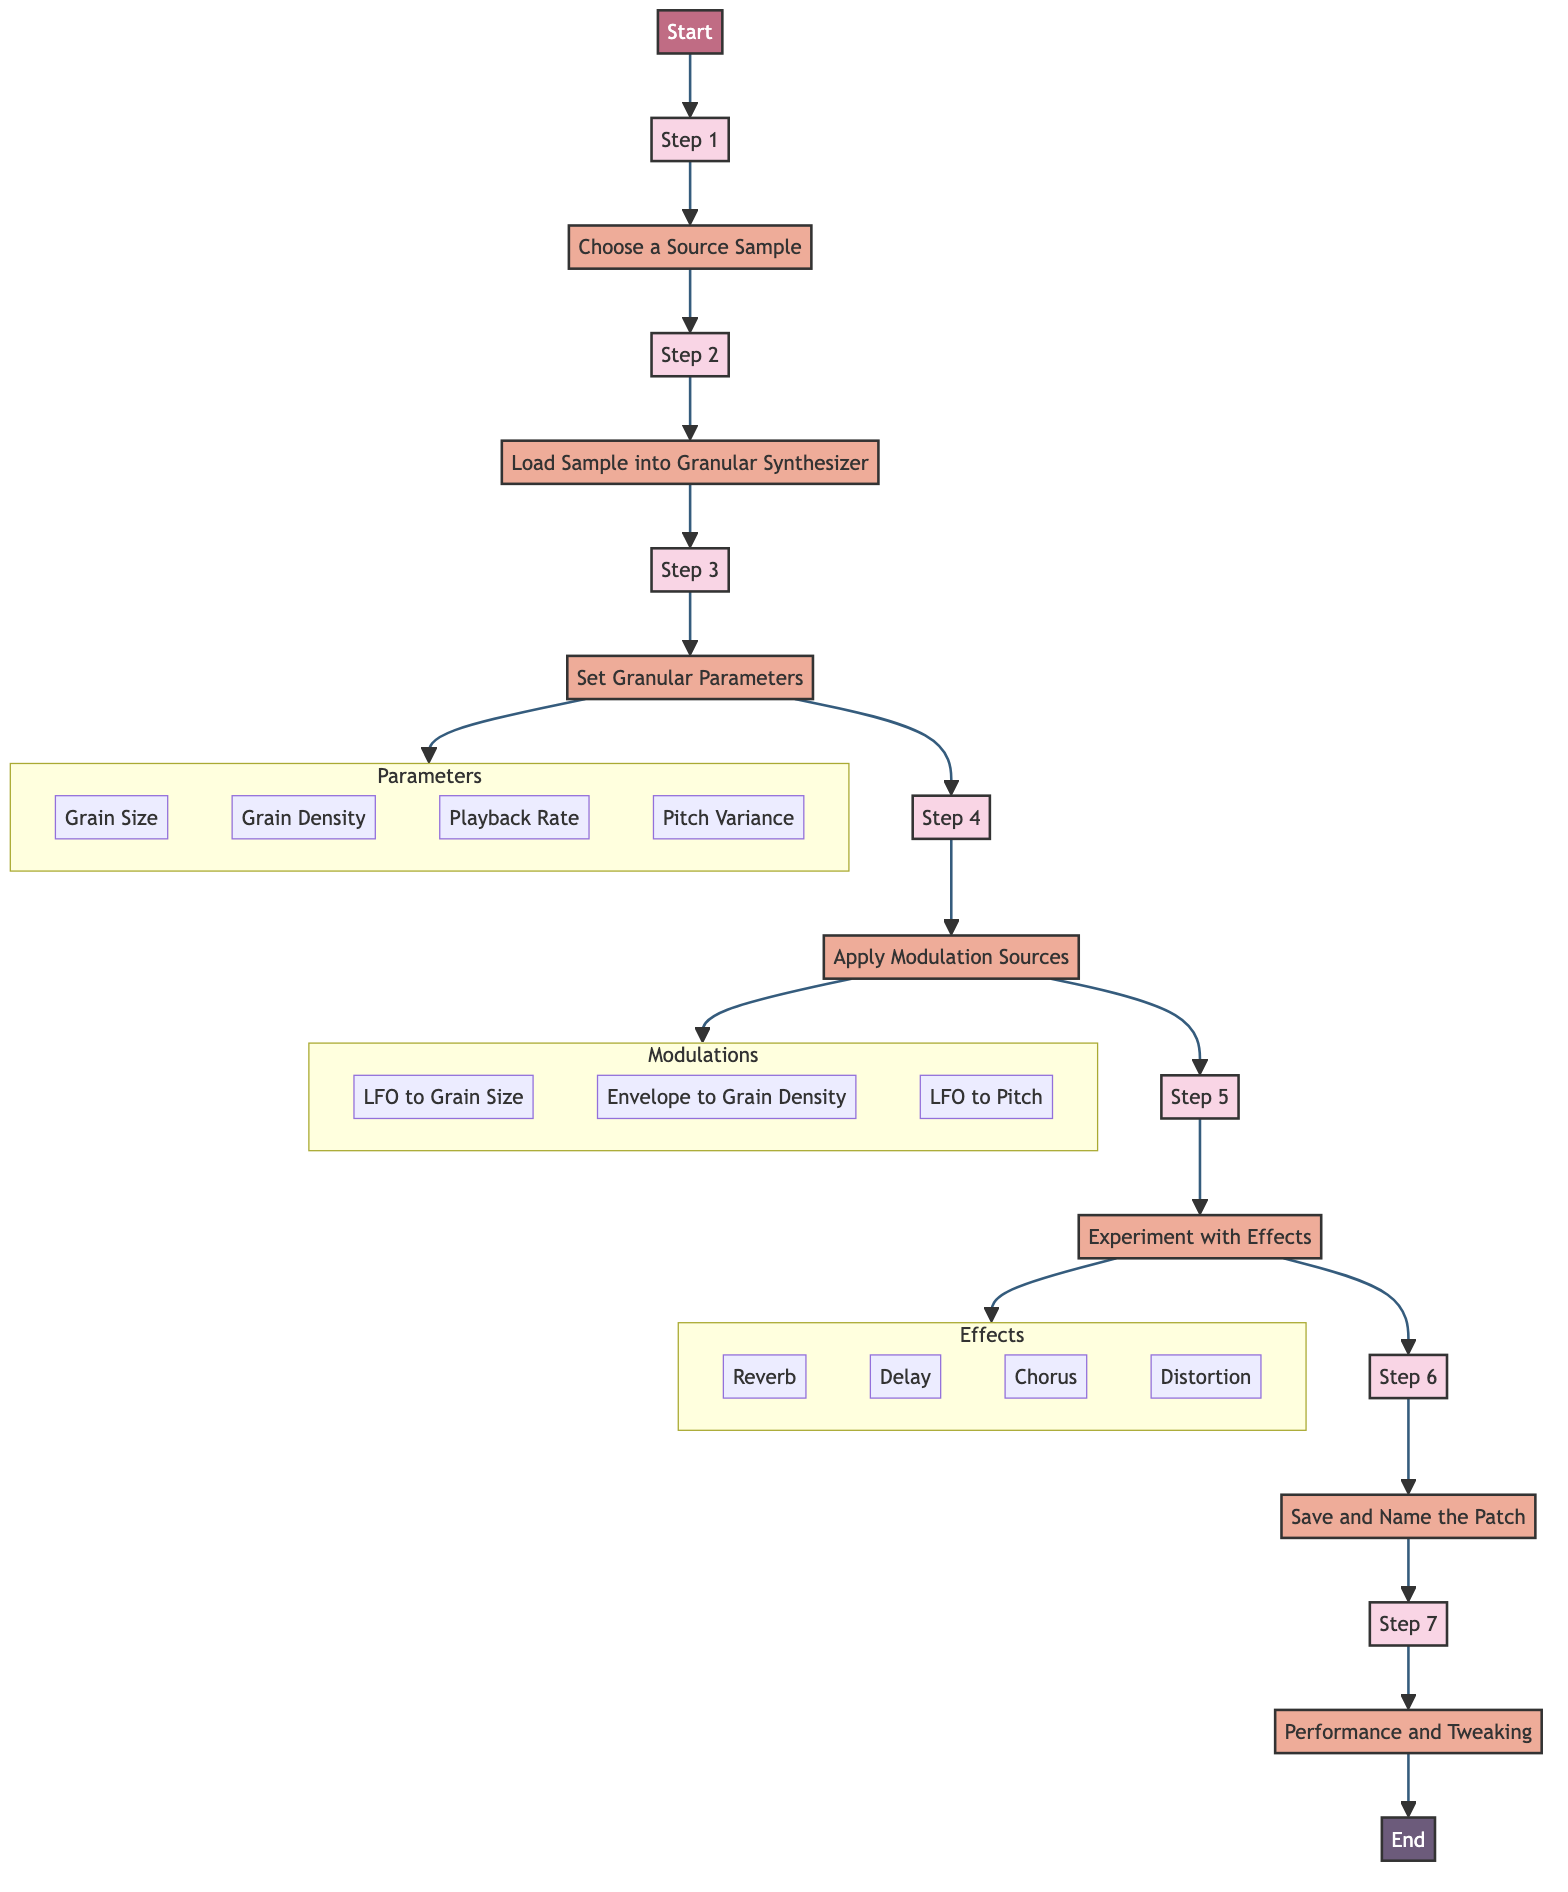What is the first action in the process? The first action is represented by Step 1 in the diagram, which is to "Choose a Source Sample."
Answer: Choose a Source Sample How many steps are in the process? The diagram indicates that there are a total of 7 steps from start to end.
Answer: 7 What action follows "Load Sample into Granular Synthesizer"? The action that follows is shown in Step 3, which is "Set Granular Parameters."
Answer: Set Granular Parameters What is one modulation source listed in the diagram? The diagram provides examples of modulation sources, one of which is "LFO to Grain Size."
Answer: LFO to Grain Size What parameter is not part of the "Set Granular Parameters" step? The diagram lists several parameters, and "Reverb" is not included in that list.
Answer: Reverb What is the last action before "Performance and Tweaking"? The step right before "Performance and Tweaking" is "Save and Name the Patch."
Answer: Save and Name the Patch What type of effects can be experimented with in Step 5? The diagram lists effects that include "Reverb," "Delay," "Chorus," and "Distortion."
Answer: Reverb, Delay, Chorus, Distortion Which step involves naming the patch? The step that involves naming the patch is Step 6, which is titled "Save and Name the Patch."
Answer: Save and Name the Patch What are the parameters to adjust in Step 3? In Step 3, the parameters that can be adjusted are Grain Size, Grain Density, Playback Rate, and Pitch Variance.
Answer: Grain Size, Grain Density, Playback Rate, Pitch Variance 